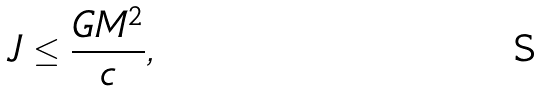Convert formula to latex. <formula><loc_0><loc_0><loc_500><loc_500>J \leq { \frac { G M ^ { 2 } } { c } } ,</formula> 